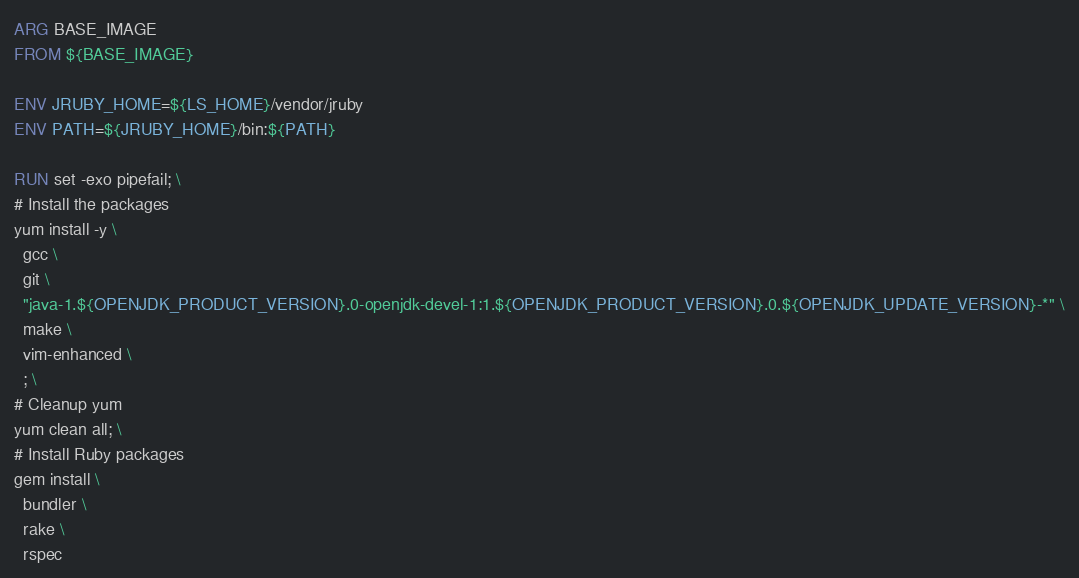<code> <loc_0><loc_0><loc_500><loc_500><_Dockerfile_>ARG BASE_IMAGE
FROM ${BASE_IMAGE}

ENV JRUBY_HOME=${LS_HOME}/vendor/jruby
ENV PATH=${JRUBY_HOME}/bin:${PATH}

RUN set -exo pipefail; \
# Install the packages
yum install -y \
  gcc \
  git \
  "java-1.${OPENJDK_PRODUCT_VERSION}.0-openjdk-devel-1:1.${OPENJDK_PRODUCT_VERSION}.0.${OPENJDK_UPDATE_VERSION}-*" \
  make \
  vim-enhanced \
  ; \
# Cleanup yum
yum clean all; \
# Install Ruby packages
gem install \
  bundler \
  rake \
  rspec
</code> 